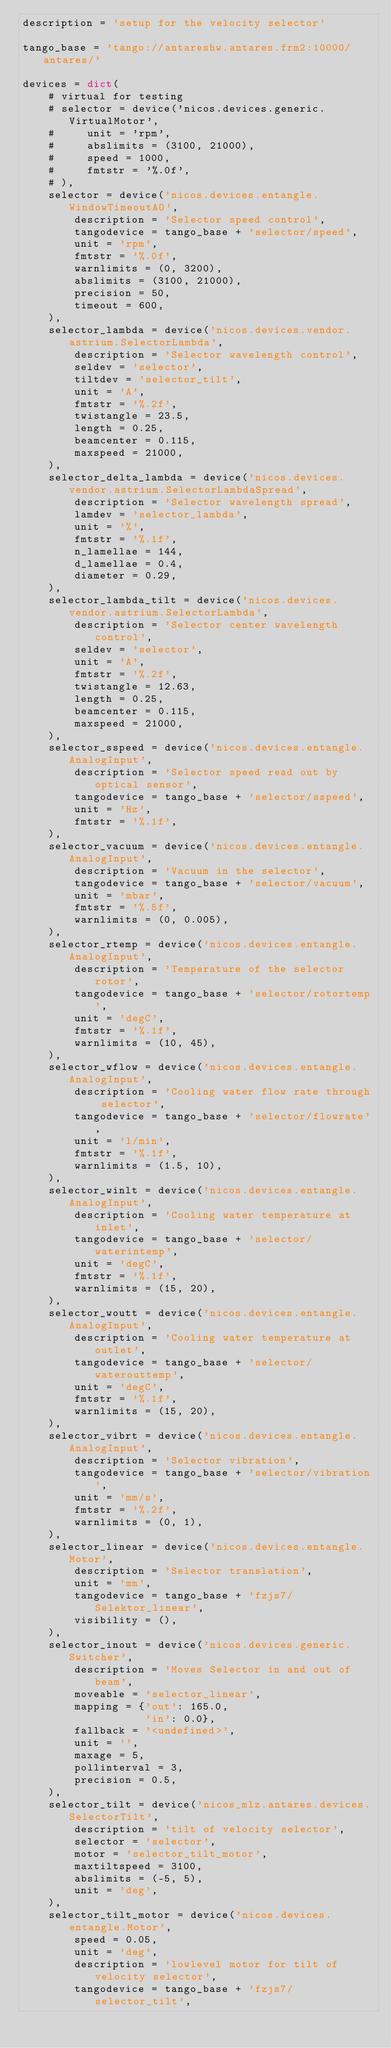Convert code to text. <code><loc_0><loc_0><loc_500><loc_500><_Python_>description = 'setup for the velocity selector'

tango_base = 'tango://antareshw.antares.frm2:10000/antares/'

devices = dict(
    # virtual for testing
    # selector = device('nicos.devices.generic.VirtualMotor',
    #     unit = 'rpm',
    #     abslimits = (3100, 21000),
    #     speed = 1000,
    #     fmtstr = '%.0f',
    # ),
    selector = device('nicos.devices.entangle.WindowTimeoutAO',
        description = 'Selector speed control',
        tangodevice = tango_base + 'selector/speed',
        unit = 'rpm',
        fmtstr = '%.0f',
        warnlimits = (0, 3200),
        abslimits = (3100, 21000),
        precision = 50,
        timeout = 600,
    ),
    selector_lambda = device('nicos.devices.vendor.astrium.SelectorLambda',
        description = 'Selector wavelength control',
        seldev = 'selector',
        tiltdev = 'selector_tilt',
        unit = 'A',
        fmtstr = '%.2f',
        twistangle = 23.5,
        length = 0.25,
        beamcenter = 0.115,
        maxspeed = 21000,
    ),
    selector_delta_lambda = device('nicos.devices.vendor.astrium.SelectorLambdaSpread',
        description = 'Selector wavelength spread',
        lamdev = 'selector_lambda',
        unit = '%',
        fmtstr = '%.1f',
        n_lamellae = 144,
        d_lamellae = 0.4,
        diameter = 0.29,
    ),
    selector_lambda_tilt = device('nicos.devices.vendor.astrium.SelectorLambda',
        description = 'Selector center wavelength control',
        seldev = 'selector',
        unit = 'A',
        fmtstr = '%.2f',
        twistangle = 12.63,
        length = 0.25,
        beamcenter = 0.115,
        maxspeed = 21000,
    ),
    selector_sspeed = device('nicos.devices.entangle.AnalogInput',
        description = 'Selector speed read out by optical sensor',
        tangodevice = tango_base + 'selector/sspeed',
        unit = 'Hz',
        fmtstr = '%.1f',
    ),
    selector_vacuum = device('nicos.devices.entangle.AnalogInput',
        description = 'Vacuum in the selector',
        tangodevice = tango_base + 'selector/vacuum',
        unit = 'mbar',
        fmtstr = '%.5f',
        warnlimits = (0, 0.005),
    ),
    selector_rtemp = device('nicos.devices.entangle.AnalogInput',
        description = 'Temperature of the selector rotor',
        tangodevice = tango_base + 'selector/rotortemp',
        unit = 'degC',
        fmtstr = '%.1f',
        warnlimits = (10, 45),
    ),
    selector_wflow = device('nicos.devices.entangle.AnalogInput',
        description = 'Cooling water flow rate through selector',
        tangodevice = tango_base + 'selector/flowrate',
        unit = 'l/min',
        fmtstr = '%.1f',
        warnlimits = (1.5, 10),
    ),
    selector_winlt = device('nicos.devices.entangle.AnalogInput',
        description = 'Cooling water temperature at inlet',
        tangodevice = tango_base + 'selector/waterintemp',
        unit = 'degC',
        fmtstr = '%.1f',
        warnlimits = (15, 20),
    ),
    selector_woutt = device('nicos.devices.entangle.AnalogInput',
        description = 'Cooling water temperature at outlet',
        tangodevice = tango_base + 'selector/waterouttemp',
        unit = 'degC',
        fmtstr = '%.1f',
        warnlimits = (15, 20),
    ),
    selector_vibrt = device('nicos.devices.entangle.AnalogInput',
        description = 'Selector vibration',
        tangodevice = tango_base + 'selector/vibration',
        unit = 'mm/s',
        fmtstr = '%.2f',
        warnlimits = (0, 1),
    ),
    selector_linear = device('nicos.devices.entangle.Motor',
        description = 'Selector translation',
        unit = 'mm',
        tangodevice = tango_base + 'fzjs7/Selektor_linear',
        visibility = (),
    ),
    selector_inout = device('nicos.devices.generic.Switcher',
        description = 'Moves Selector in and out of beam',
        moveable = 'selector_linear',
        mapping = {'out': 165.0,
                   'in': 0.0},
        fallback = '<undefined>',
        unit = '',
        maxage = 5,
        pollinterval = 3,
        precision = 0.5,
    ),
    selector_tilt = device('nicos_mlz.antares.devices.SelectorTilt',
        description = 'tilt of velocity selector',
        selector = 'selector',
        motor = 'selector_tilt_motor',
        maxtiltspeed = 3100,
        abslimits = (-5, 5),
        unit = 'deg',
    ),
    selector_tilt_motor = device('nicos.devices.entangle.Motor',
        speed = 0.05,
        unit = 'deg',
        description = 'lowlevel motor for tilt of velocity selector',
        tangodevice = tango_base + 'fzjs7/selector_tilt',</code> 